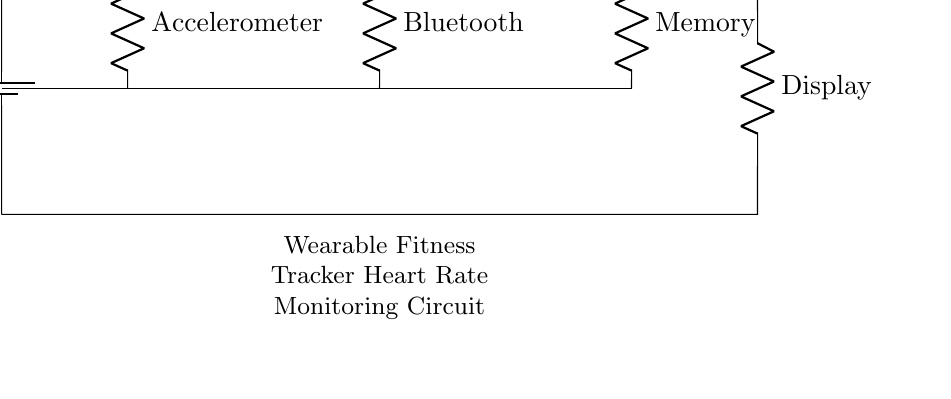What is the power source in this circuit? The circuit includes a battery, indicated by the component labeled as Battery, which provides the necessary voltage to power the circuit.
Answer: Battery How many primary components are connected in series? By counting the resistors listed, we find five primary components (Microcontroller, LED, Heart Rate Sensor, Display, and an additional component for connections).
Answer: Five What does the heart rate sensor do? The heart rate sensor is connected in series and is specifically designated to monitor heart rate, reading the pulse signals from the body.
Answer: Monitor heart rate Which component monitors movement in this circuit? The component labeled as Accelerometer is responsible for detecting and monitoring motion, which can be related to the user's activity level.
Answer: Accelerometer What is the primary function of the microcontroller? The microcontroller in this circuit processes data from various sensors (like heart rate) and manages communication with other components.
Answer: Data processing What does the Bluetooth component facilitate? The Bluetooth component enables wireless communication by allowing the wearable fitness tracker to transmit data to other devices, such as smartphones or computers.
Answer: Wireless communication Which component displays the heart rate information? The Display component receives data from the heart rate sensor and visually presents the heart rate readings to the user.
Answer: Display 